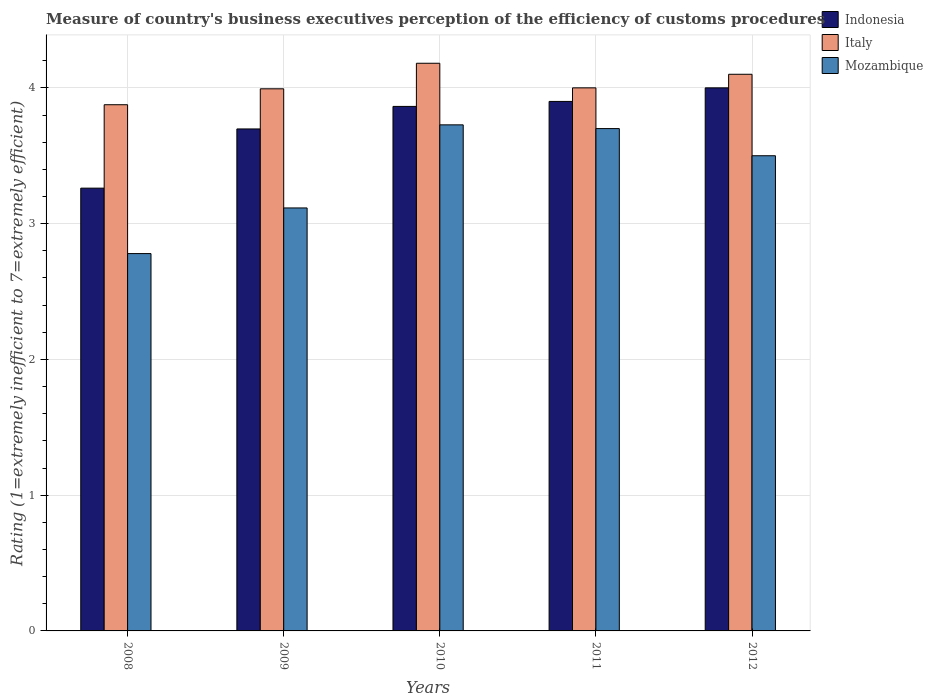How many different coloured bars are there?
Give a very brief answer. 3. Are the number of bars per tick equal to the number of legend labels?
Your answer should be compact. Yes. How many bars are there on the 5th tick from the left?
Keep it short and to the point. 3. Across all years, what is the maximum rating of the efficiency of customs procedure in Indonesia?
Provide a short and direct response. 4. Across all years, what is the minimum rating of the efficiency of customs procedure in Italy?
Make the answer very short. 3.88. In which year was the rating of the efficiency of customs procedure in Mozambique maximum?
Keep it short and to the point. 2010. What is the total rating of the efficiency of customs procedure in Italy in the graph?
Offer a terse response. 20.15. What is the difference between the rating of the efficiency of customs procedure in Mozambique in 2009 and that in 2011?
Provide a short and direct response. -0.58. What is the average rating of the efficiency of customs procedure in Mozambique per year?
Provide a short and direct response. 3.36. In the year 2009, what is the difference between the rating of the efficiency of customs procedure in Indonesia and rating of the efficiency of customs procedure in Mozambique?
Your response must be concise. 0.58. What is the ratio of the rating of the efficiency of customs procedure in Mozambique in 2008 to that in 2009?
Keep it short and to the point. 0.89. Is the difference between the rating of the efficiency of customs procedure in Indonesia in 2008 and 2010 greater than the difference between the rating of the efficiency of customs procedure in Mozambique in 2008 and 2010?
Provide a short and direct response. Yes. What is the difference between the highest and the second highest rating of the efficiency of customs procedure in Italy?
Offer a very short reply. 0.08. What is the difference between the highest and the lowest rating of the efficiency of customs procedure in Mozambique?
Offer a very short reply. 0.95. What does the 3rd bar from the right in 2010 represents?
Offer a terse response. Indonesia. Is it the case that in every year, the sum of the rating of the efficiency of customs procedure in Indonesia and rating of the efficiency of customs procedure in Italy is greater than the rating of the efficiency of customs procedure in Mozambique?
Ensure brevity in your answer.  Yes. How many bars are there?
Offer a very short reply. 15. Are all the bars in the graph horizontal?
Your answer should be very brief. No. How many years are there in the graph?
Your answer should be very brief. 5. Where does the legend appear in the graph?
Offer a very short reply. Top right. How many legend labels are there?
Offer a very short reply. 3. How are the legend labels stacked?
Provide a short and direct response. Vertical. What is the title of the graph?
Your response must be concise. Measure of country's business executives perception of the efficiency of customs procedures. Does "Cuba" appear as one of the legend labels in the graph?
Ensure brevity in your answer.  No. What is the label or title of the Y-axis?
Provide a succinct answer. Rating (1=extremely inefficient to 7=extremely efficient). What is the Rating (1=extremely inefficient to 7=extremely efficient) in Indonesia in 2008?
Your response must be concise. 3.26. What is the Rating (1=extremely inefficient to 7=extremely efficient) in Italy in 2008?
Keep it short and to the point. 3.88. What is the Rating (1=extremely inefficient to 7=extremely efficient) in Mozambique in 2008?
Offer a very short reply. 2.78. What is the Rating (1=extremely inefficient to 7=extremely efficient) of Indonesia in 2009?
Your answer should be compact. 3.7. What is the Rating (1=extremely inefficient to 7=extremely efficient) in Italy in 2009?
Provide a succinct answer. 3.99. What is the Rating (1=extremely inefficient to 7=extremely efficient) in Mozambique in 2009?
Your answer should be very brief. 3.12. What is the Rating (1=extremely inefficient to 7=extremely efficient) in Indonesia in 2010?
Your response must be concise. 3.86. What is the Rating (1=extremely inefficient to 7=extremely efficient) of Italy in 2010?
Your answer should be compact. 4.18. What is the Rating (1=extremely inefficient to 7=extremely efficient) of Mozambique in 2010?
Keep it short and to the point. 3.73. What is the Rating (1=extremely inefficient to 7=extremely efficient) in Indonesia in 2011?
Offer a terse response. 3.9. Across all years, what is the maximum Rating (1=extremely inefficient to 7=extremely efficient) of Italy?
Keep it short and to the point. 4.18. Across all years, what is the maximum Rating (1=extremely inefficient to 7=extremely efficient) in Mozambique?
Provide a succinct answer. 3.73. Across all years, what is the minimum Rating (1=extremely inefficient to 7=extremely efficient) in Indonesia?
Provide a short and direct response. 3.26. Across all years, what is the minimum Rating (1=extremely inefficient to 7=extremely efficient) in Italy?
Provide a succinct answer. 3.88. Across all years, what is the minimum Rating (1=extremely inefficient to 7=extremely efficient) of Mozambique?
Give a very brief answer. 2.78. What is the total Rating (1=extremely inefficient to 7=extremely efficient) of Indonesia in the graph?
Provide a succinct answer. 18.72. What is the total Rating (1=extremely inefficient to 7=extremely efficient) of Italy in the graph?
Ensure brevity in your answer.  20.15. What is the total Rating (1=extremely inefficient to 7=extremely efficient) of Mozambique in the graph?
Your response must be concise. 16.82. What is the difference between the Rating (1=extremely inefficient to 7=extremely efficient) in Indonesia in 2008 and that in 2009?
Offer a terse response. -0.44. What is the difference between the Rating (1=extremely inefficient to 7=extremely efficient) in Italy in 2008 and that in 2009?
Offer a terse response. -0.12. What is the difference between the Rating (1=extremely inefficient to 7=extremely efficient) of Mozambique in 2008 and that in 2009?
Keep it short and to the point. -0.34. What is the difference between the Rating (1=extremely inefficient to 7=extremely efficient) of Indonesia in 2008 and that in 2010?
Your answer should be compact. -0.6. What is the difference between the Rating (1=extremely inefficient to 7=extremely efficient) in Italy in 2008 and that in 2010?
Ensure brevity in your answer.  -0.31. What is the difference between the Rating (1=extremely inefficient to 7=extremely efficient) of Mozambique in 2008 and that in 2010?
Make the answer very short. -0.95. What is the difference between the Rating (1=extremely inefficient to 7=extremely efficient) in Indonesia in 2008 and that in 2011?
Your answer should be compact. -0.64. What is the difference between the Rating (1=extremely inefficient to 7=extremely efficient) of Italy in 2008 and that in 2011?
Provide a short and direct response. -0.12. What is the difference between the Rating (1=extremely inefficient to 7=extremely efficient) in Mozambique in 2008 and that in 2011?
Your response must be concise. -0.92. What is the difference between the Rating (1=extremely inefficient to 7=extremely efficient) in Indonesia in 2008 and that in 2012?
Give a very brief answer. -0.74. What is the difference between the Rating (1=extremely inefficient to 7=extremely efficient) of Italy in 2008 and that in 2012?
Ensure brevity in your answer.  -0.22. What is the difference between the Rating (1=extremely inefficient to 7=extremely efficient) of Mozambique in 2008 and that in 2012?
Your response must be concise. -0.72. What is the difference between the Rating (1=extremely inefficient to 7=extremely efficient) of Indonesia in 2009 and that in 2010?
Provide a short and direct response. -0.17. What is the difference between the Rating (1=extremely inefficient to 7=extremely efficient) of Italy in 2009 and that in 2010?
Make the answer very short. -0.19. What is the difference between the Rating (1=extremely inefficient to 7=extremely efficient) of Mozambique in 2009 and that in 2010?
Provide a succinct answer. -0.61. What is the difference between the Rating (1=extremely inefficient to 7=extremely efficient) in Indonesia in 2009 and that in 2011?
Your response must be concise. -0.2. What is the difference between the Rating (1=extremely inefficient to 7=extremely efficient) in Italy in 2009 and that in 2011?
Provide a succinct answer. -0.01. What is the difference between the Rating (1=extremely inefficient to 7=extremely efficient) of Mozambique in 2009 and that in 2011?
Keep it short and to the point. -0.58. What is the difference between the Rating (1=extremely inefficient to 7=extremely efficient) in Indonesia in 2009 and that in 2012?
Offer a very short reply. -0.3. What is the difference between the Rating (1=extremely inefficient to 7=extremely efficient) in Italy in 2009 and that in 2012?
Your answer should be very brief. -0.11. What is the difference between the Rating (1=extremely inefficient to 7=extremely efficient) in Mozambique in 2009 and that in 2012?
Provide a succinct answer. -0.38. What is the difference between the Rating (1=extremely inefficient to 7=extremely efficient) of Indonesia in 2010 and that in 2011?
Give a very brief answer. -0.04. What is the difference between the Rating (1=extremely inefficient to 7=extremely efficient) of Italy in 2010 and that in 2011?
Make the answer very short. 0.18. What is the difference between the Rating (1=extremely inefficient to 7=extremely efficient) of Mozambique in 2010 and that in 2011?
Your answer should be very brief. 0.03. What is the difference between the Rating (1=extremely inefficient to 7=extremely efficient) in Indonesia in 2010 and that in 2012?
Provide a short and direct response. -0.14. What is the difference between the Rating (1=extremely inefficient to 7=extremely efficient) of Italy in 2010 and that in 2012?
Your answer should be compact. 0.08. What is the difference between the Rating (1=extremely inefficient to 7=extremely efficient) of Mozambique in 2010 and that in 2012?
Your answer should be very brief. 0.23. What is the difference between the Rating (1=extremely inefficient to 7=extremely efficient) in Italy in 2011 and that in 2012?
Provide a short and direct response. -0.1. What is the difference between the Rating (1=extremely inefficient to 7=extremely efficient) of Mozambique in 2011 and that in 2012?
Give a very brief answer. 0.2. What is the difference between the Rating (1=extremely inefficient to 7=extremely efficient) in Indonesia in 2008 and the Rating (1=extremely inefficient to 7=extremely efficient) in Italy in 2009?
Give a very brief answer. -0.73. What is the difference between the Rating (1=extremely inefficient to 7=extremely efficient) in Indonesia in 2008 and the Rating (1=extremely inefficient to 7=extremely efficient) in Mozambique in 2009?
Provide a short and direct response. 0.15. What is the difference between the Rating (1=extremely inefficient to 7=extremely efficient) of Italy in 2008 and the Rating (1=extremely inefficient to 7=extremely efficient) of Mozambique in 2009?
Offer a terse response. 0.76. What is the difference between the Rating (1=extremely inefficient to 7=extremely efficient) of Indonesia in 2008 and the Rating (1=extremely inefficient to 7=extremely efficient) of Italy in 2010?
Keep it short and to the point. -0.92. What is the difference between the Rating (1=extremely inefficient to 7=extremely efficient) in Indonesia in 2008 and the Rating (1=extremely inefficient to 7=extremely efficient) in Mozambique in 2010?
Offer a very short reply. -0.47. What is the difference between the Rating (1=extremely inefficient to 7=extremely efficient) in Italy in 2008 and the Rating (1=extremely inefficient to 7=extremely efficient) in Mozambique in 2010?
Offer a very short reply. 0.15. What is the difference between the Rating (1=extremely inefficient to 7=extremely efficient) of Indonesia in 2008 and the Rating (1=extremely inefficient to 7=extremely efficient) of Italy in 2011?
Offer a very short reply. -0.74. What is the difference between the Rating (1=extremely inefficient to 7=extremely efficient) of Indonesia in 2008 and the Rating (1=extremely inefficient to 7=extremely efficient) of Mozambique in 2011?
Offer a very short reply. -0.44. What is the difference between the Rating (1=extremely inefficient to 7=extremely efficient) in Italy in 2008 and the Rating (1=extremely inefficient to 7=extremely efficient) in Mozambique in 2011?
Offer a terse response. 0.18. What is the difference between the Rating (1=extremely inefficient to 7=extremely efficient) in Indonesia in 2008 and the Rating (1=extremely inefficient to 7=extremely efficient) in Italy in 2012?
Your answer should be very brief. -0.84. What is the difference between the Rating (1=extremely inefficient to 7=extremely efficient) in Indonesia in 2008 and the Rating (1=extremely inefficient to 7=extremely efficient) in Mozambique in 2012?
Provide a succinct answer. -0.24. What is the difference between the Rating (1=extremely inefficient to 7=extremely efficient) of Italy in 2008 and the Rating (1=extremely inefficient to 7=extremely efficient) of Mozambique in 2012?
Offer a terse response. 0.38. What is the difference between the Rating (1=extremely inefficient to 7=extremely efficient) of Indonesia in 2009 and the Rating (1=extremely inefficient to 7=extremely efficient) of Italy in 2010?
Ensure brevity in your answer.  -0.48. What is the difference between the Rating (1=extremely inefficient to 7=extremely efficient) of Indonesia in 2009 and the Rating (1=extremely inefficient to 7=extremely efficient) of Mozambique in 2010?
Your answer should be compact. -0.03. What is the difference between the Rating (1=extremely inefficient to 7=extremely efficient) of Italy in 2009 and the Rating (1=extremely inefficient to 7=extremely efficient) of Mozambique in 2010?
Provide a short and direct response. 0.27. What is the difference between the Rating (1=extremely inefficient to 7=extremely efficient) in Indonesia in 2009 and the Rating (1=extremely inefficient to 7=extremely efficient) in Italy in 2011?
Your response must be concise. -0.3. What is the difference between the Rating (1=extremely inefficient to 7=extremely efficient) in Indonesia in 2009 and the Rating (1=extremely inefficient to 7=extremely efficient) in Mozambique in 2011?
Make the answer very short. -0. What is the difference between the Rating (1=extremely inefficient to 7=extremely efficient) of Italy in 2009 and the Rating (1=extremely inefficient to 7=extremely efficient) of Mozambique in 2011?
Provide a short and direct response. 0.29. What is the difference between the Rating (1=extremely inefficient to 7=extremely efficient) of Indonesia in 2009 and the Rating (1=extremely inefficient to 7=extremely efficient) of Italy in 2012?
Keep it short and to the point. -0.4. What is the difference between the Rating (1=extremely inefficient to 7=extremely efficient) of Indonesia in 2009 and the Rating (1=extremely inefficient to 7=extremely efficient) of Mozambique in 2012?
Keep it short and to the point. 0.2. What is the difference between the Rating (1=extremely inefficient to 7=extremely efficient) in Italy in 2009 and the Rating (1=extremely inefficient to 7=extremely efficient) in Mozambique in 2012?
Offer a terse response. 0.49. What is the difference between the Rating (1=extremely inefficient to 7=extremely efficient) in Indonesia in 2010 and the Rating (1=extremely inefficient to 7=extremely efficient) in Italy in 2011?
Offer a very short reply. -0.14. What is the difference between the Rating (1=extremely inefficient to 7=extremely efficient) in Indonesia in 2010 and the Rating (1=extremely inefficient to 7=extremely efficient) in Mozambique in 2011?
Your answer should be very brief. 0.16. What is the difference between the Rating (1=extremely inefficient to 7=extremely efficient) of Italy in 2010 and the Rating (1=extremely inefficient to 7=extremely efficient) of Mozambique in 2011?
Keep it short and to the point. 0.48. What is the difference between the Rating (1=extremely inefficient to 7=extremely efficient) of Indonesia in 2010 and the Rating (1=extremely inefficient to 7=extremely efficient) of Italy in 2012?
Your answer should be compact. -0.24. What is the difference between the Rating (1=extremely inefficient to 7=extremely efficient) in Indonesia in 2010 and the Rating (1=extremely inefficient to 7=extremely efficient) in Mozambique in 2012?
Make the answer very short. 0.36. What is the difference between the Rating (1=extremely inefficient to 7=extremely efficient) of Italy in 2010 and the Rating (1=extremely inefficient to 7=extremely efficient) of Mozambique in 2012?
Offer a very short reply. 0.68. What is the difference between the Rating (1=extremely inefficient to 7=extremely efficient) of Indonesia in 2011 and the Rating (1=extremely inefficient to 7=extremely efficient) of Italy in 2012?
Make the answer very short. -0.2. What is the difference between the Rating (1=extremely inefficient to 7=extremely efficient) in Indonesia in 2011 and the Rating (1=extremely inefficient to 7=extremely efficient) in Mozambique in 2012?
Your answer should be compact. 0.4. What is the average Rating (1=extremely inefficient to 7=extremely efficient) of Indonesia per year?
Ensure brevity in your answer.  3.74. What is the average Rating (1=extremely inefficient to 7=extremely efficient) in Italy per year?
Offer a very short reply. 4.03. What is the average Rating (1=extremely inefficient to 7=extremely efficient) in Mozambique per year?
Your answer should be very brief. 3.36. In the year 2008, what is the difference between the Rating (1=extremely inefficient to 7=extremely efficient) of Indonesia and Rating (1=extremely inefficient to 7=extremely efficient) of Italy?
Offer a very short reply. -0.61. In the year 2008, what is the difference between the Rating (1=extremely inefficient to 7=extremely efficient) in Indonesia and Rating (1=extremely inefficient to 7=extremely efficient) in Mozambique?
Offer a very short reply. 0.48. In the year 2008, what is the difference between the Rating (1=extremely inefficient to 7=extremely efficient) in Italy and Rating (1=extremely inefficient to 7=extremely efficient) in Mozambique?
Ensure brevity in your answer.  1.1. In the year 2009, what is the difference between the Rating (1=extremely inefficient to 7=extremely efficient) of Indonesia and Rating (1=extremely inefficient to 7=extremely efficient) of Italy?
Your answer should be compact. -0.3. In the year 2009, what is the difference between the Rating (1=extremely inefficient to 7=extremely efficient) of Indonesia and Rating (1=extremely inefficient to 7=extremely efficient) of Mozambique?
Provide a succinct answer. 0.58. In the year 2009, what is the difference between the Rating (1=extremely inefficient to 7=extremely efficient) in Italy and Rating (1=extremely inefficient to 7=extremely efficient) in Mozambique?
Offer a very short reply. 0.88. In the year 2010, what is the difference between the Rating (1=extremely inefficient to 7=extremely efficient) of Indonesia and Rating (1=extremely inefficient to 7=extremely efficient) of Italy?
Provide a succinct answer. -0.32. In the year 2010, what is the difference between the Rating (1=extremely inefficient to 7=extremely efficient) of Indonesia and Rating (1=extremely inefficient to 7=extremely efficient) of Mozambique?
Provide a succinct answer. 0.14. In the year 2010, what is the difference between the Rating (1=extremely inefficient to 7=extremely efficient) in Italy and Rating (1=extremely inefficient to 7=extremely efficient) in Mozambique?
Provide a short and direct response. 0.45. In the year 2011, what is the difference between the Rating (1=extremely inefficient to 7=extremely efficient) of Indonesia and Rating (1=extremely inefficient to 7=extremely efficient) of Italy?
Your answer should be very brief. -0.1. In the year 2011, what is the difference between the Rating (1=extremely inefficient to 7=extremely efficient) in Indonesia and Rating (1=extremely inefficient to 7=extremely efficient) in Mozambique?
Give a very brief answer. 0.2. In the year 2012, what is the difference between the Rating (1=extremely inefficient to 7=extremely efficient) of Indonesia and Rating (1=extremely inefficient to 7=extremely efficient) of Italy?
Give a very brief answer. -0.1. In the year 2012, what is the difference between the Rating (1=extremely inefficient to 7=extremely efficient) in Indonesia and Rating (1=extremely inefficient to 7=extremely efficient) in Mozambique?
Provide a succinct answer. 0.5. What is the ratio of the Rating (1=extremely inefficient to 7=extremely efficient) in Indonesia in 2008 to that in 2009?
Provide a succinct answer. 0.88. What is the ratio of the Rating (1=extremely inefficient to 7=extremely efficient) of Italy in 2008 to that in 2009?
Your answer should be compact. 0.97. What is the ratio of the Rating (1=extremely inefficient to 7=extremely efficient) in Mozambique in 2008 to that in 2009?
Your response must be concise. 0.89. What is the ratio of the Rating (1=extremely inefficient to 7=extremely efficient) of Indonesia in 2008 to that in 2010?
Your response must be concise. 0.84. What is the ratio of the Rating (1=extremely inefficient to 7=extremely efficient) in Italy in 2008 to that in 2010?
Your answer should be very brief. 0.93. What is the ratio of the Rating (1=extremely inefficient to 7=extremely efficient) of Mozambique in 2008 to that in 2010?
Ensure brevity in your answer.  0.75. What is the ratio of the Rating (1=extremely inefficient to 7=extremely efficient) in Indonesia in 2008 to that in 2011?
Your answer should be very brief. 0.84. What is the ratio of the Rating (1=extremely inefficient to 7=extremely efficient) of Italy in 2008 to that in 2011?
Offer a very short reply. 0.97. What is the ratio of the Rating (1=extremely inefficient to 7=extremely efficient) of Mozambique in 2008 to that in 2011?
Ensure brevity in your answer.  0.75. What is the ratio of the Rating (1=extremely inefficient to 7=extremely efficient) of Indonesia in 2008 to that in 2012?
Your response must be concise. 0.82. What is the ratio of the Rating (1=extremely inefficient to 7=extremely efficient) in Italy in 2008 to that in 2012?
Provide a short and direct response. 0.95. What is the ratio of the Rating (1=extremely inefficient to 7=extremely efficient) of Mozambique in 2008 to that in 2012?
Keep it short and to the point. 0.79. What is the ratio of the Rating (1=extremely inefficient to 7=extremely efficient) in Indonesia in 2009 to that in 2010?
Provide a short and direct response. 0.96. What is the ratio of the Rating (1=extremely inefficient to 7=extremely efficient) in Italy in 2009 to that in 2010?
Offer a terse response. 0.95. What is the ratio of the Rating (1=extremely inefficient to 7=extremely efficient) of Mozambique in 2009 to that in 2010?
Give a very brief answer. 0.84. What is the ratio of the Rating (1=extremely inefficient to 7=extremely efficient) in Indonesia in 2009 to that in 2011?
Your response must be concise. 0.95. What is the ratio of the Rating (1=extremely inefficient to 7=extremely efficient) of Italy in 2009 to that in 2011?
Keep it short and to the point. 1. What is the ratio of the Rating (1=extremely inefficient to 7=extremely efficient) of Mozambique in 2009 to that in 2011?
Offer a very short reply. 0.84. What is the ratio of the Rating (1=extremely inefficient to 7=extremely efficient) of Indonesia in 2009 to that in 2012?
Your answer should be compact. 0.92. What is the ratio of the Rating (1=extremely inefficient to 7=extremely efficient) in Italy in 2009 to that in 2012?
Give a very brief answer. 0.97. What is the ratio of the Rating (1=extremely inefficient to 7=extremely efficient) in Mozambique in 2009 to that in 2012?
Keep it short and to the point. 0.89. What is the ratio of the Rating (1=extremely inefficient to 7=extremely efficient) in Indonesia in 2010 to that in 2011?
Your response must be concise. 0.99. What is the ratio of the Rating (1=extremely inefficient to 7=extremely efficient) in Italy in 2010 to that in 2011?
Make the answer very short. 1.05. What is the ratio of the Rating (1=extremely inefficient to 7=extremely efficient) of Mozambique in 2010 to that in 2011?
Your answer should be very brief. 1.01. What is the ratio of the Rating (1=extremely inefficient to 7=extremely efficient) in Indonesia in 2010 to that in 2012?
Keep it short and to the point. 0.97. What is the ratio of the Rating (1=extremely inefficient to 7=extremely efficient) of Italy in 2010 to that in 2012?
Ensure brevity in your answer.  1.02. What is the ratio of the Rating (1=extremely inefficient to 7=extremely efficient) of Mozambique in 2010 to that in 2012?
Your answer should be very brief. 1.06. What is the ratio of the Rating (1=extremely inefficient to 7=extremely efficient) of Indonesia in 2011 to that in 2012?
Offer a terse response. 0.97. What is the ratio of the Rating (1=extremely inefficient to 7=extremely efficient) in Italy in 2011 to that in 2012?
Offer a very short reply. 0.98. What is the ratio of the Rating (1=extremely inefficient to 7=extremely efficient) in Mozambique in 2011 to that in 2012?
Ensure brevity in your answer.  1.06. What is the difference between the highest and the second highest Rating (1=extremely inefficient to 7=extremely efficient) in Italy?
Provide a succinct answer. 0.08. What is the difference between the highest and the second highest Rating (1=extremely inefficient to 7=extremely efficient) in Mozambique?
Your answer should be compact. 0.03. What is the difference between the highest and the lowest Rating (1=extremely inefficient to 7=extremely efficient) in Indonesia?
Give a very brief answer. 0.74. What is the difference between the highest and the lowest Rating (1=extremely inefficient to 7=extremely efficient) of Italy?
Provide a short and direct response. 0.31. What is the difference between the highest and the lowest Rating (1=extremely inefficient to 7=extremely efficient) in Mozambique?
Your response must be concise. 0.95. 